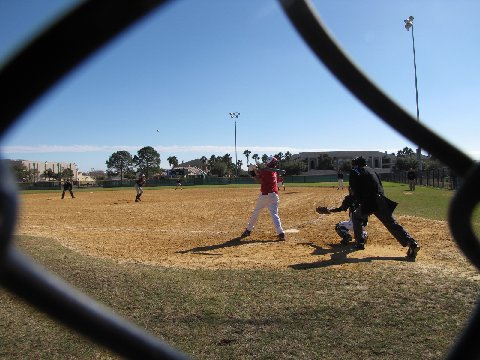What is another player doing during the game? Another devoted player, clad in a matching team outfit, is intently positioned on the dirt-covered field. The player's poise suggests readiness to spring into action, indicating the readiness and anticipation that underpins the roles of all participants in this dynamic game. 